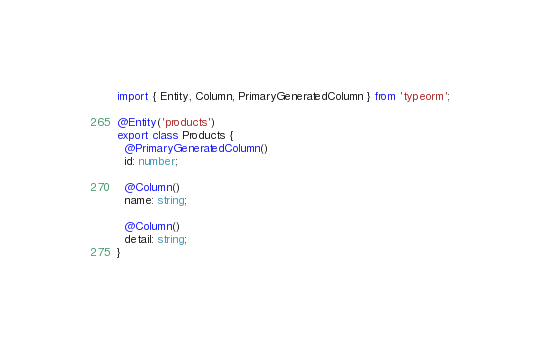<code> <loc_0><loc_0><loc_500><loc_500><_TypeScript_>import { Entity, Column, PrimaryGeneratedColumn } from 'typeorm';

@Entity('products')
export class Products {
  @PrimaryGeneratedColumn()
  id: number;

  @Column()
  name: string;

  @Column()
  detail: string;
}
</code> 